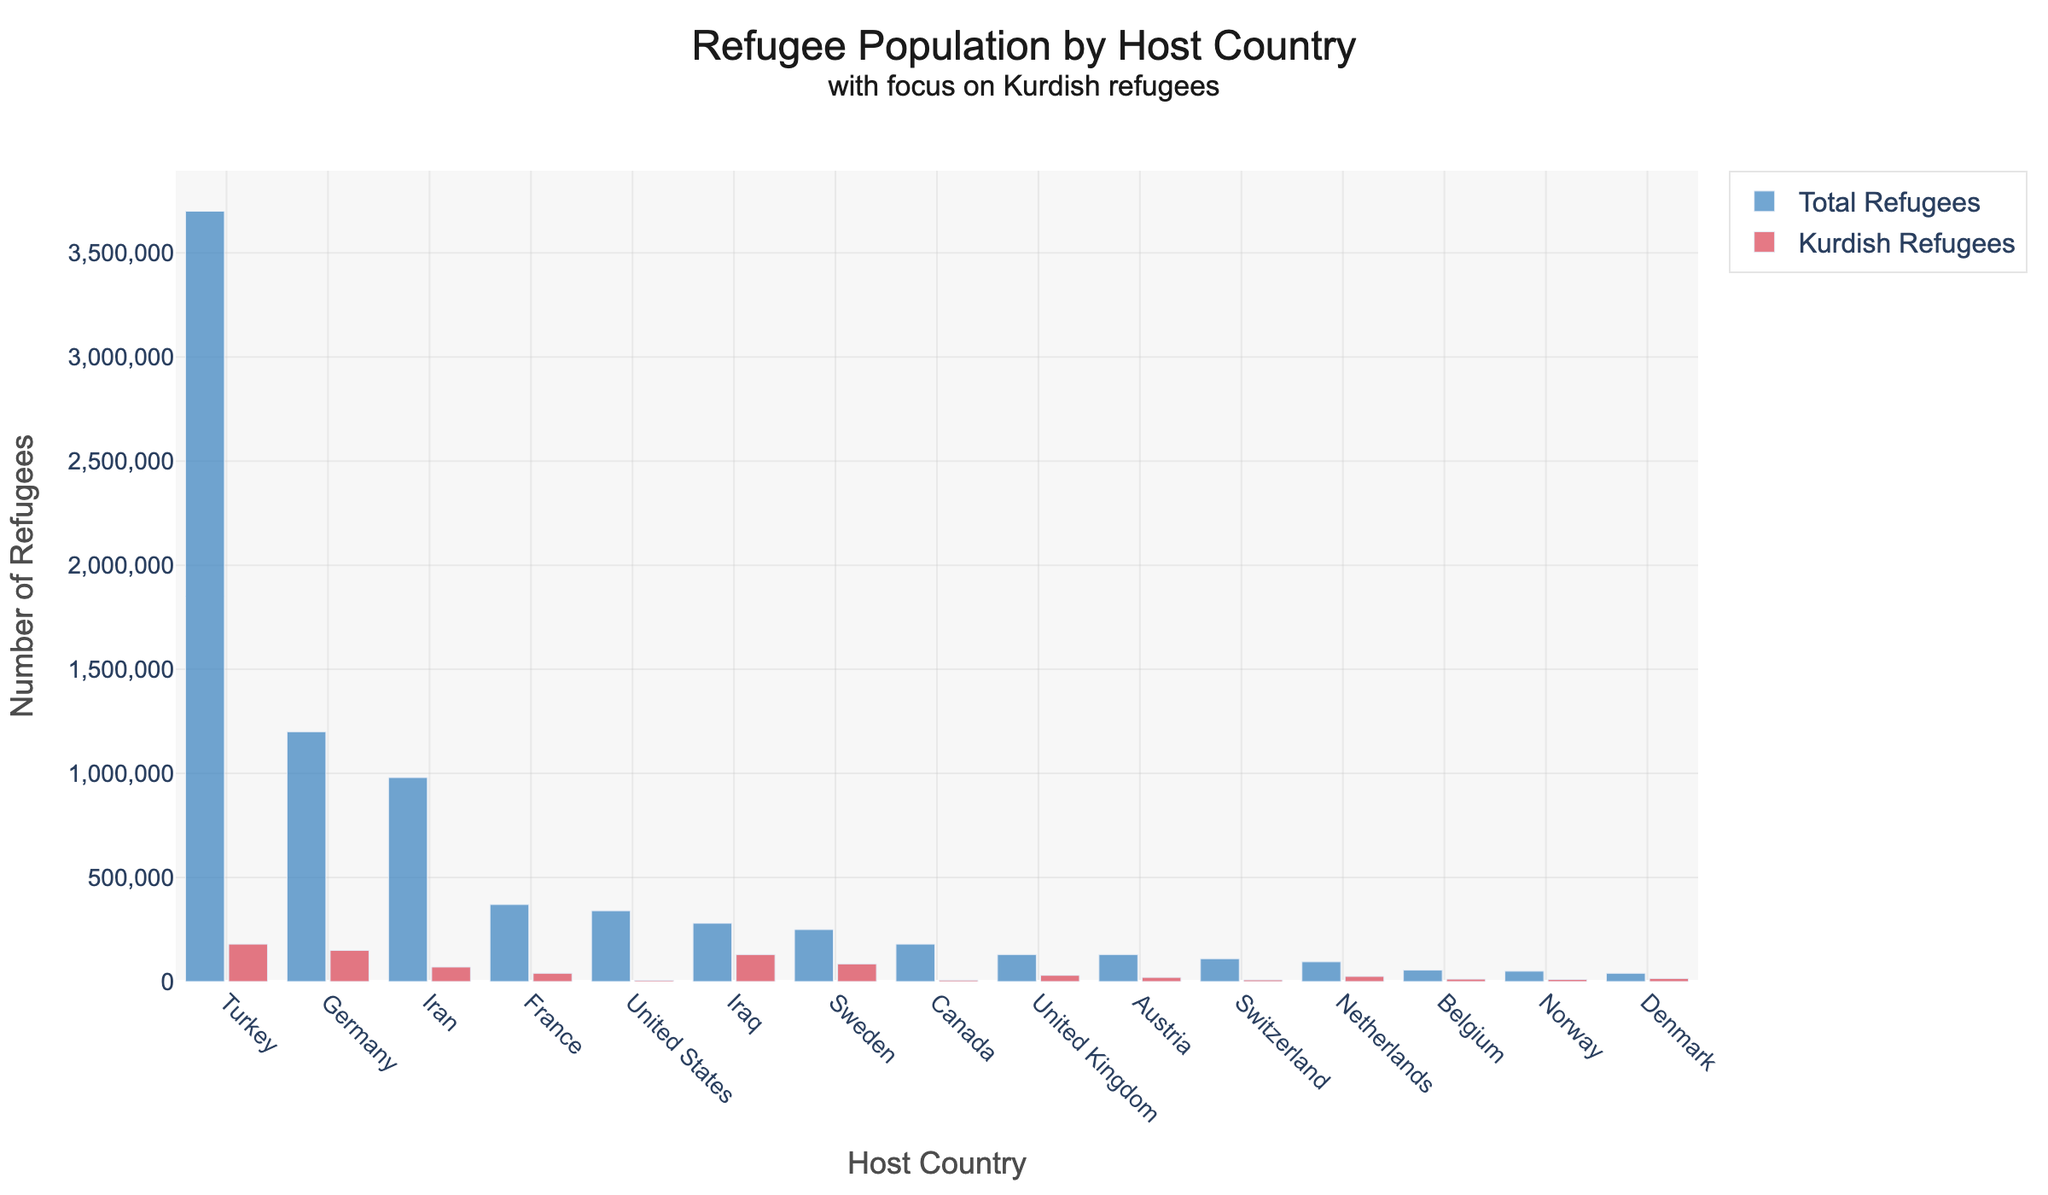What's the total number of Kurdish refugees in Germany and Iraq combined? Germany has 150,000 Kurdish refugees and Iraq has 130,000 Kurdish refugees. Combining these gives 150,000 + 130,000 = 280,000.
Answer: 280,000 Which country hosts the greatest number of total refugees? From the bar chart, Turkey has the highest bar for Total Refugees indicating it hosts the most refugees.
Answer: Turkey What is the difference in the number of Kurdish refugees between Turkey and Sweden? Turkey hosts 180,000 Kurdish refugees, and Sweden hosts 85,000. The difference can be calculated as 180,000 - 85,000 = 95,000.
Answer: 95,000 Among the listed countries, which one has the smallest number of Kurdish refugees? The United States hosts the smallest number of Kurdish refugees with a value of 6,000.
Answer: United States Which country has a higher number of Kurdish refugees: France or the United Kingdom? France has 40,000 Kurdish refugees, while the United Kingdom has 30,000 Kurdish refugees. Therefore, France has a higher number.
Answer: France How does the height of the bar representing total refugees in Germany compare to the bar representing total refugees in Iran? The bar representing total refugees in Germany is taller than the bar representing total refugees in Iran, indicating Germany hosts more refugees than Iran.
Answer: Germany has more refugees What fraction of the total refugees in Turkey are Kurdish refugees? Turkey hosts 3,700,000 total refugees and 180,000 Kurdish refugees. The fraction can be calculated as 180,000 / 3,700,000 = 0.0486 or approximately 4.86%.
Answer: 4.86% Are there more Kurdish refugees in Netherlands or Denmark, and by how much? The Netherlands has 25,000 Kurdish refugees while Denmark has 15,000 Kurdish refugees. Therefore, the Netherlands has 25,000 - 15,000 = 10,000 more Kurdish refugees than Denmark.
Answer: Netherlands by 10,000 Which country has the longest bar for Kurdish refugees after Turkey? After Turkey, Germany has the longest bar for Kurdish refugees, indicating that it hosts the second highest number of Kurdish refugees.
Answer: Germany 